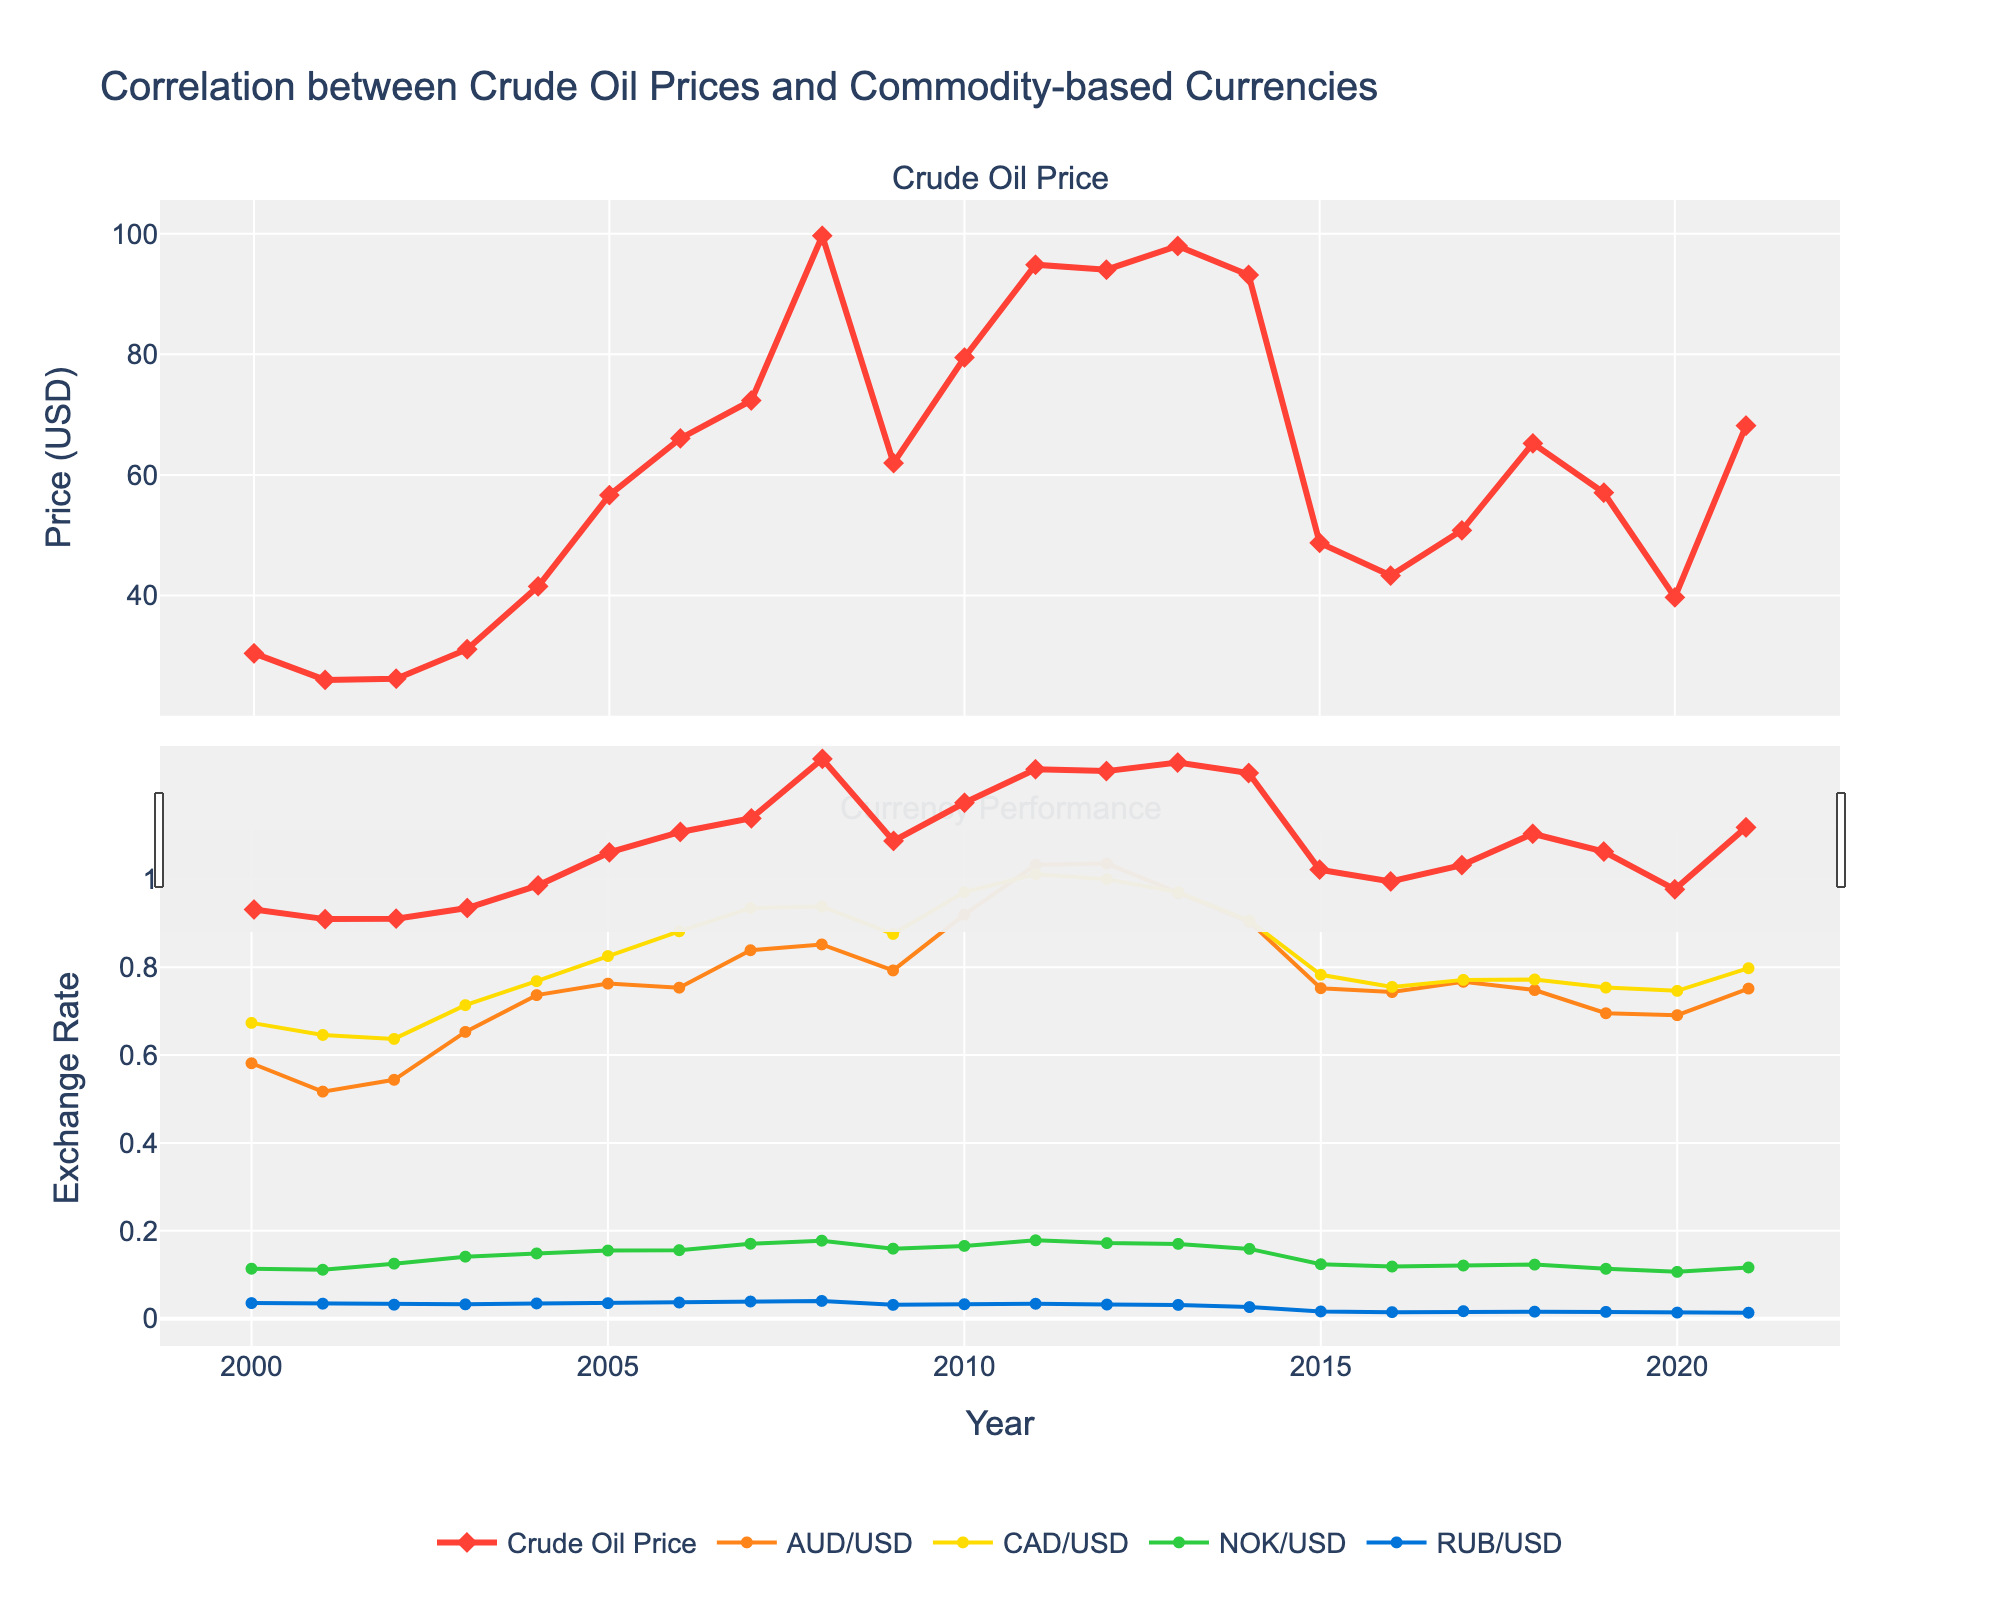What was the highest crude oil price during the period shown, and in which year did it occur? By examining the line for "Crude Oil Price", the peak can be identified visually. The highest point corresponds to 2008 with a price of $99.67.
Answer: 2008, $99.67 How did the AUD/USD exchange rate change from 2000 to 2021? Locate the start and end points of the "AUD/USD" series. The value in 2000 is 0.5814, and in 2021 it is 0.7514. To find the change: 0.7514 - 0.5814 = 0.17.
Answer: Increased by 0.17 Which currency shows the most significant drop in exchange rate along with the crude oil price between 2008 and 2009? Look at the exchange rates for all four currencies between 2008 and 2009. The RUB/USD dropped from 0.0404 to 0.0315, a decrease of 0.0089. Compare this drop to others; it's the largest.
Answer: RUB/USD What is the trend of CAD/USD exchange rate relative to crude oil prices from 2005 to 2015? Inspect the "CAD/USD" and "Crude Oil Price" lines between 2005 and 2015. Both exhibit a general upward trend until 2008, dropping significantly after, and declining around 2014-2015. This indicates a correlation where CAD/USD tends to follow the crude oil price trend.
Answer: Similar trend Which year has the least correlation between crude oil prices and currency exchange rates based on visual inspection? Look for the year where crude oil price trend differs significantly from exchange rates. In 2020, the sharp drop in oil prices contrasts with relatively stable exchange rates, indicating lesser correlation.
Answer: 2020 During which years did the NOK/USD exchange rate increase despite a decrease in crude oil prices? Identify the years with a decrease in crude oil prices and cross-check with the NOK/USD trajectory. In 2002, the oil price dropped from 2001, but NOK/USD increased from 0.1114 to 0.1253.
Answer: 2002 Which currency seems to have the strongest visual correlation with crude oil over the entire period? Observe the overall fluctuations and trends. CAD/USD appears to mirror the crude oil price more closely than other currencies, indicating a strong correlation.
Answer: CAD/USD By how much did the crude oil price change from its lowest to its highest point, and over which years did this change occur? Determine the lowest and highest crude oil prices by examining the plot. The lowest ($25.98) in 2001 and highest ($99.67) in 2008. The change is 99.67 - 25.98 = 73.69.
Answer: $73.69, from 2001 to 2008 